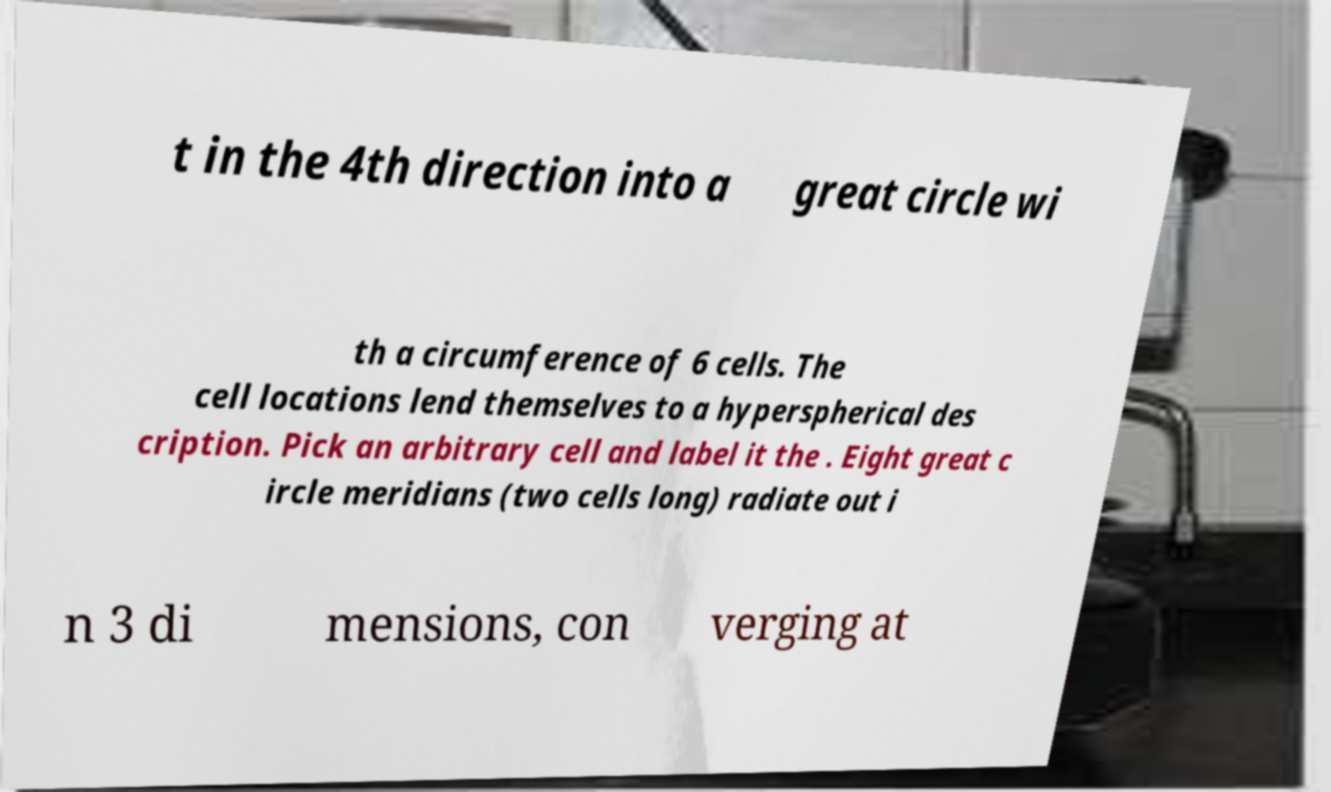What messages or text are displayed in this image? I need them in a readable, typed format. t in the 4th direction into a great circle wi th a circumference of 6 cells. The cell locations lend themselves to a hyperspherical des cription. Pick an arbitrary cell and label it the . Eight great c ircle meridians (two cells long) radiate out i n 3 di mensions, con verging at 